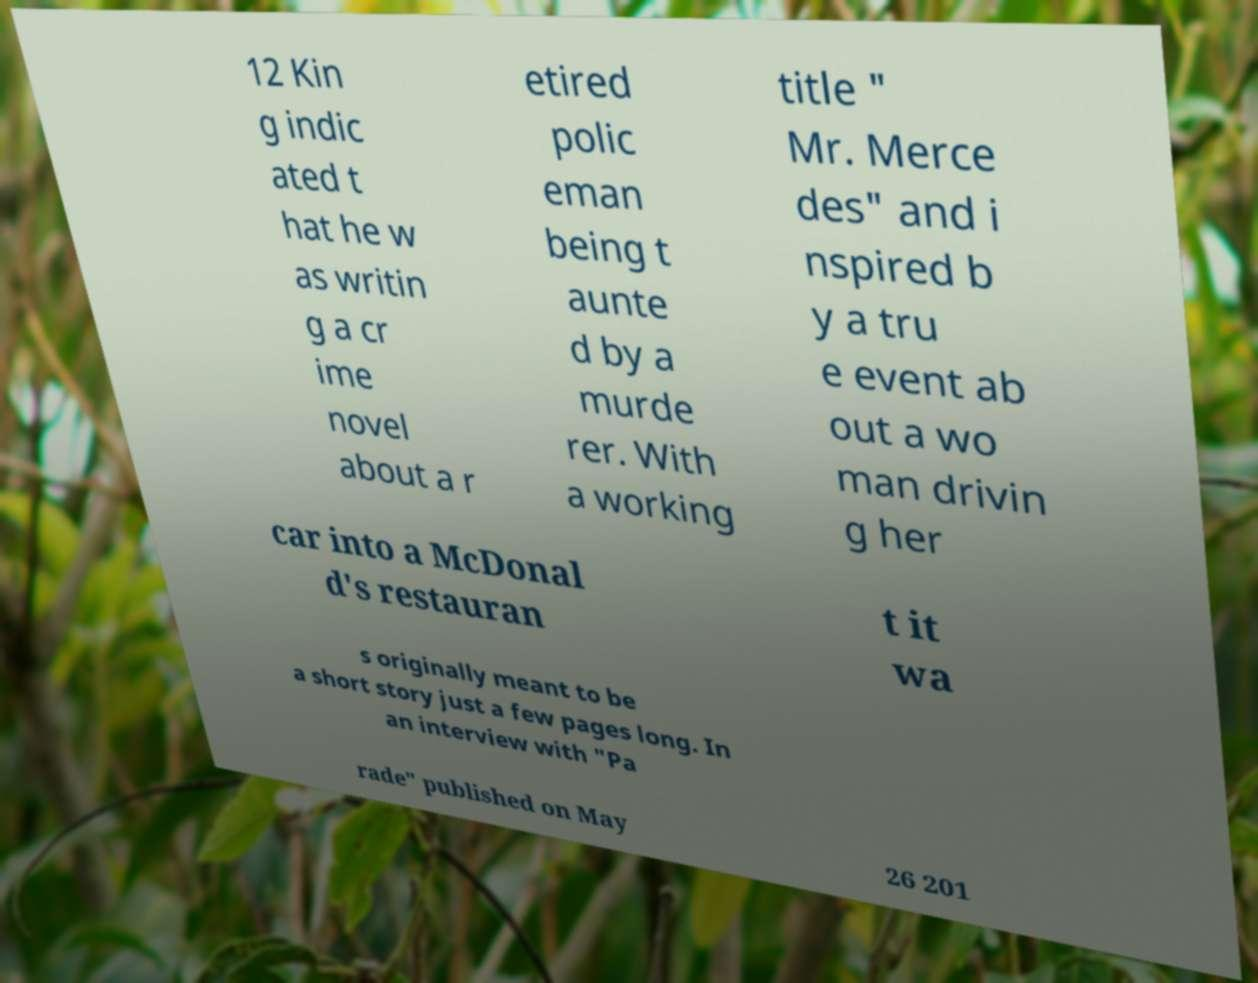I need the written content from this picture converted into text. Can you do that? 12 Kin g indic ated t hat he w as writin g a cr ime novel about a r etired polic eman being t aunte d by a murde rer. With a working title " Mr. Merce des" and i nspired b y a tru e event ab out a wo man drivin g her car into a McDonal d's restauran t it wa s originally meant to be a short story just a few pages long. In an interview with "Pa rade" published on May 26 201 